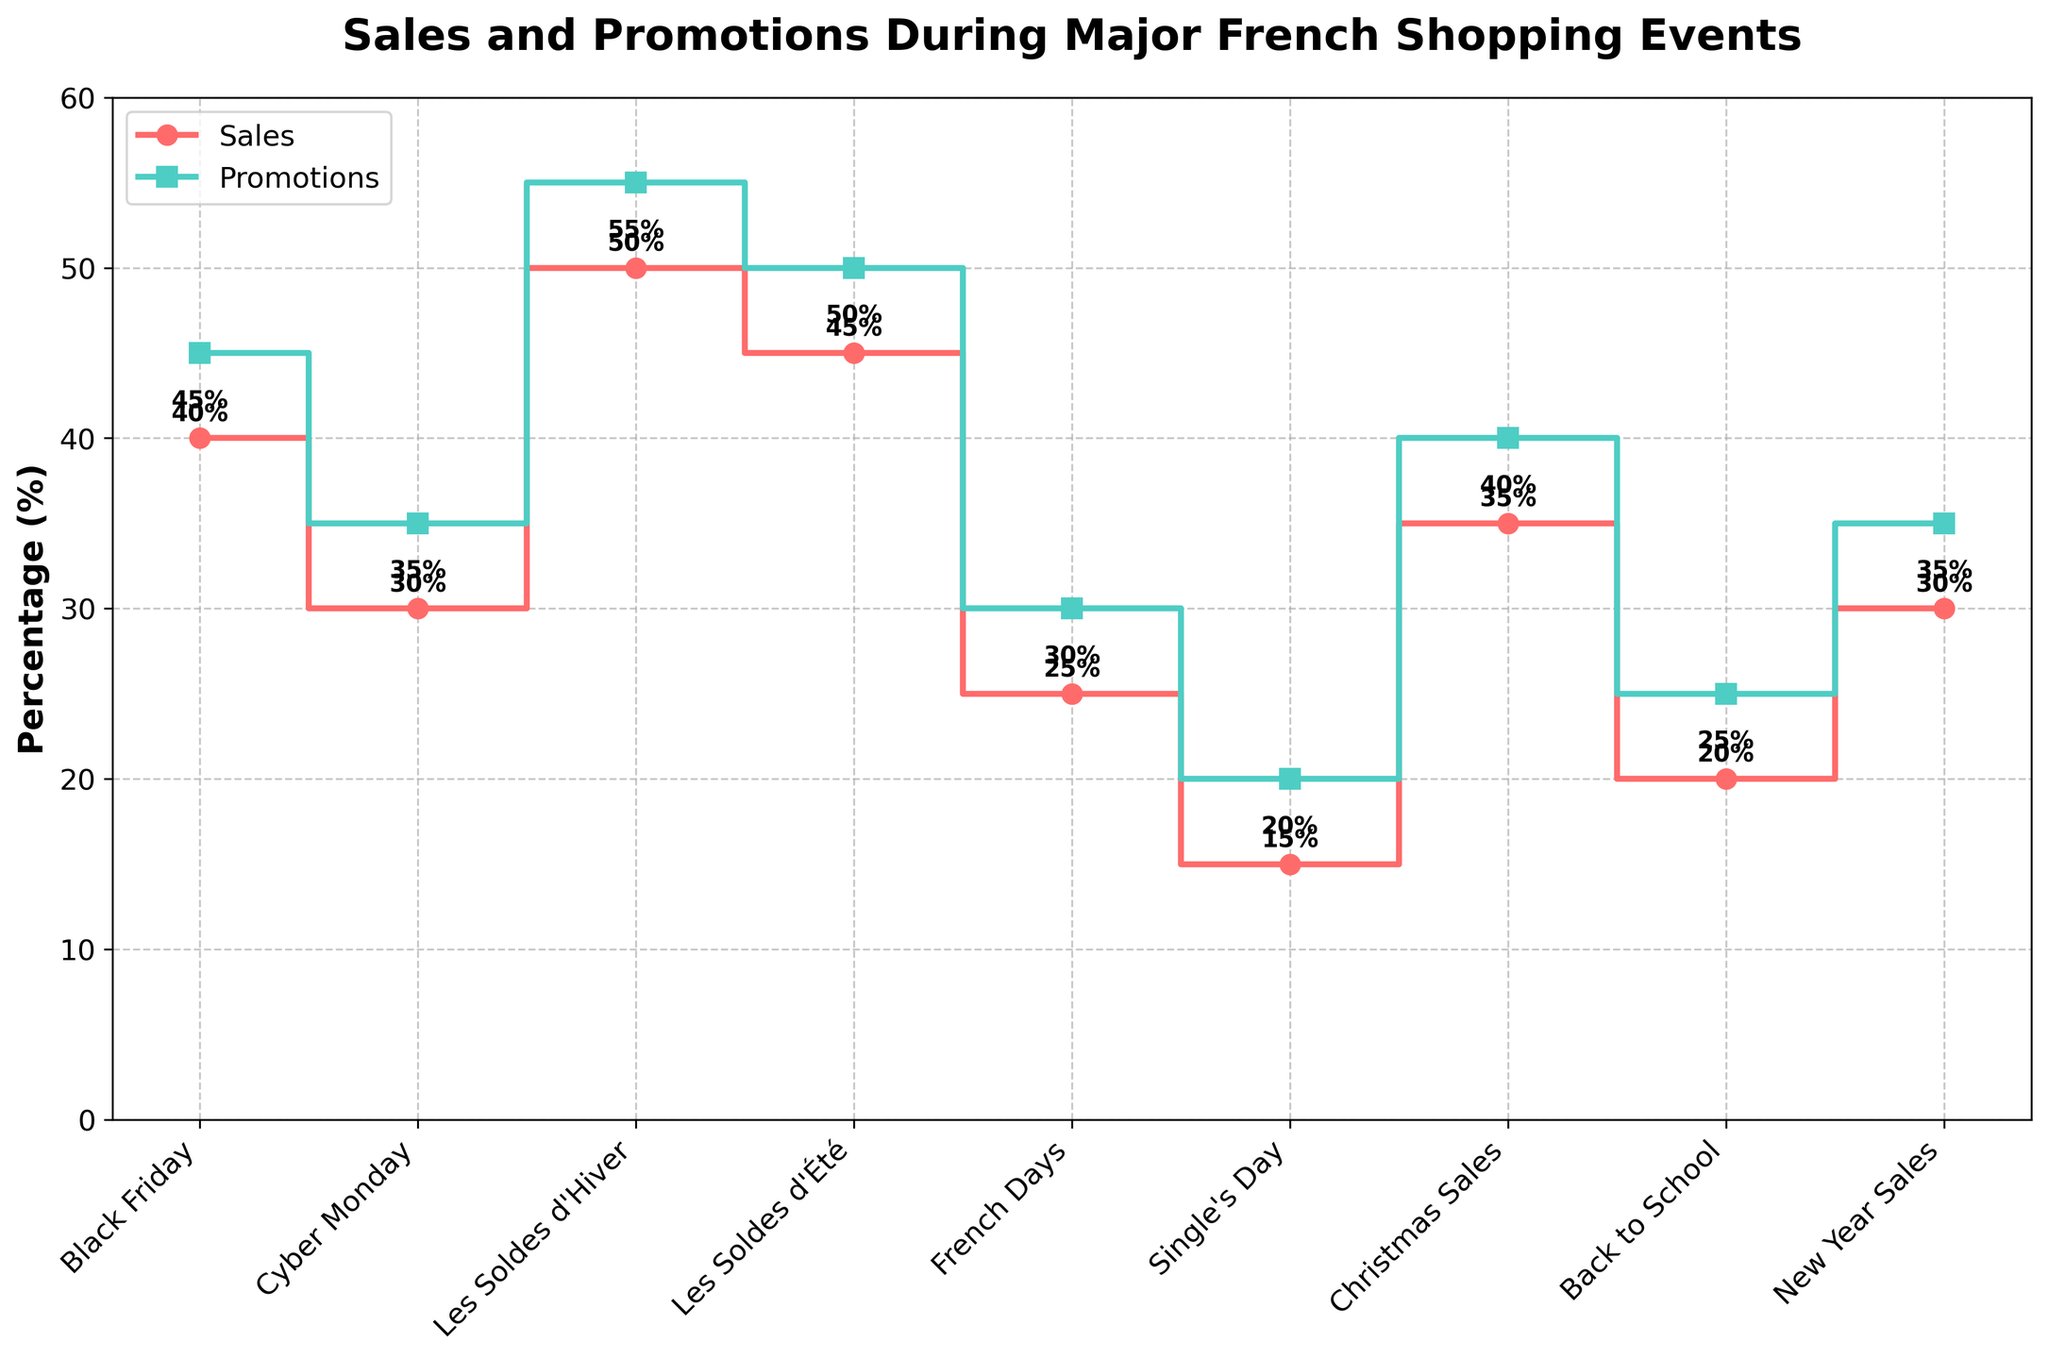What's the title of the figure? The title of the figure is prominently displayed at the top of the plot and describes the main purpose of the visual.
Answer: Sales and Promotions During Major French Shopping Events What is the maximum percentage of sales during the depicted shopping events? Look for the highest value on the step plot for sales. The highest step for sales is labeled as 50%.
Answer: 50% Which event has the smallest difference between sales and promotions percentages? Calculate the difference between sales and promotions for each event and identify the smallest one. For Single's Day: 5%, for Back to School: 5%, both have the smallest differences.
Answer: Single's Day and Back to School How many events have both sales and promotions percentages over 40%? Look at each event and check both sales and promotions percentages. Count the events where both percentages exceed 40%. Les Soldes d'Hiver (50%, 55%), Les Soldes d'Été (45%, 50%) and Black Friday (40%, 45%).
Answer: 3 Which shopping event shows the greatest percentage of promotions? Identify the highest value on the step plot for promotions. Les Soldes d'Hiver has the highest promotions value, which is 55%.
Answer: Les Soldes d'Hiver What is the average percentage of promotions across all events? Sum all the percentages of promotions and divide by the number of events. (45 + 35 + 55 + 50 + 30 + 20 + 40 + 25 + 35) / 9 = 335 / 9 ≈ 37.22%
Answer: 37.22% Do any events have the same percentage value for both sales and promotions? Compare the sales and promotions percentages for each event to see if they are ever equal. No events have equal percentages.
Answer: No How does the percentage of promotions for Cyber Monday compare to New Year Sales? Look at the promotion percentages for both events on the step plot. Cyber Monday has 35%, and New Year Sales also has 35%.
Answer: They are equal Which event shows the largest increase in sales percentage compared to the previous event listed? Calculate the difference in sales percentages between consecutive events on the plot and look for the largest increase. Les Soldes d'Hiver from Cyber Monday has an increase of 20% (50% - 30%).
Answer: Les Soldes d'Hiver Which events fall below an average promotions percentage of 37.22%? Compare each event's promotions percentage to the given average. French Days (30%), Single's Day (20%), Back to School (25%), New Year Sales (35%).
Answer: French Days, Single's Day, Back to School, and New Year Sales 